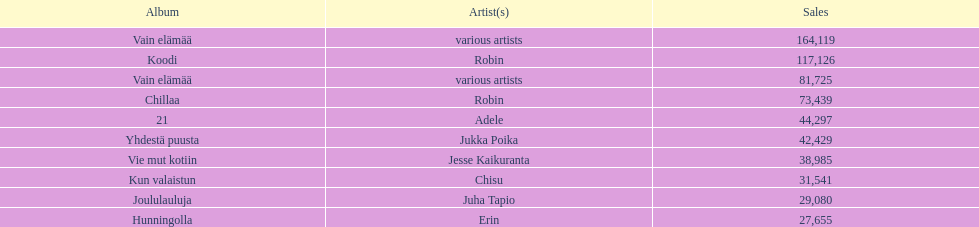Tell me what album had the most sold. Vain elämää. 